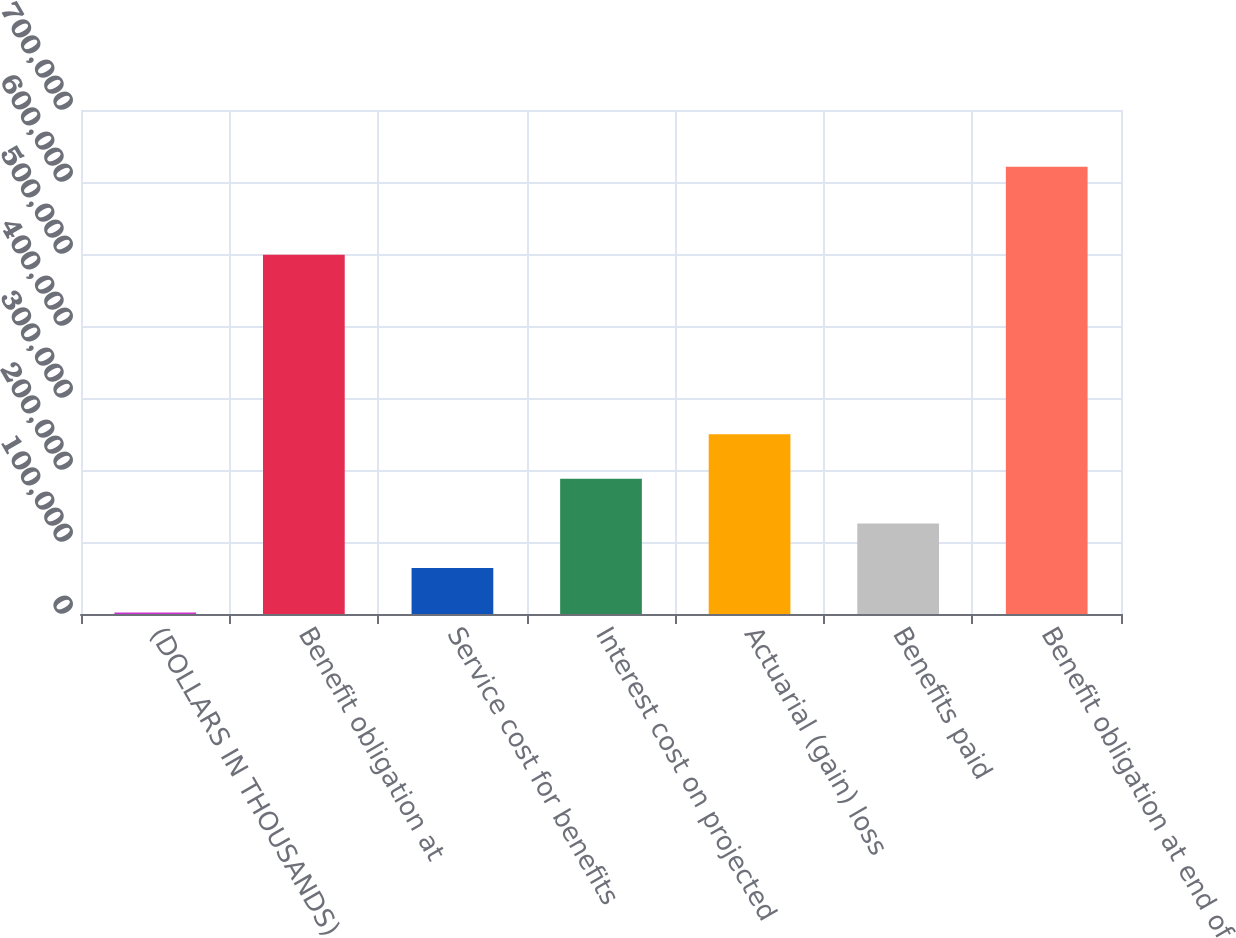Convert chart. <chart><loc_0><loc_0><loc_500><loc_500><bar_chart><fcel>(DOLLARS IN THOUSANDS)<fcel>Benefit obligation at<fcel>Service cost for benefits<fcel>Interest cost on projected<fcel>Actuarial (gain) loss<fcel>Benefits paid<fcel>Benefit obligation at end of<nl><fcel>2009<fcel>499004<fcel>63934<fcel>187784<fcel>249709<fcel>125859<fcel>621259<nl></chart> 